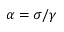<formula> <loc_0><loc_0><loc_500><loc_500>\alpha = \sigma / \gamma</formula> 